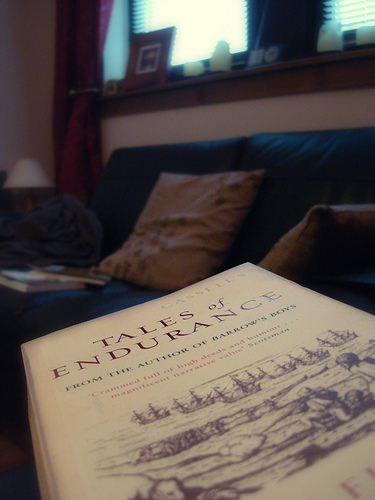<image>
Is the book on the couch? Yes. Looking at the image, I can see the book is positioned on top of the couch, with the couch providing support. 